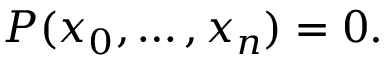Convert formula to latex. <formula><loc_0><loc_0><loc_500><loc_500>P ( x _ { 0 } , \dots , x _ { n } ) = 0 .</formula> 